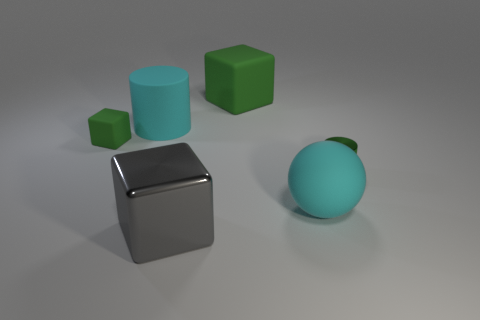Can you compare the textures of the different objects in the image? Certainly! The large green cube has a matte texture that diffuses light evenly, resulting in no noticeable reflections. The green metal cylinder has a reflective, shiny surface which clearly mirrors the environment and light source. The blue spherical object also exhibits a matte texture, but with a slightly rougher surface quality than the green cube. Lastly, the silver cube at the front has a highly reflective metallic texture, similar to a mirror, that provides clear reflections of its surroundings. 